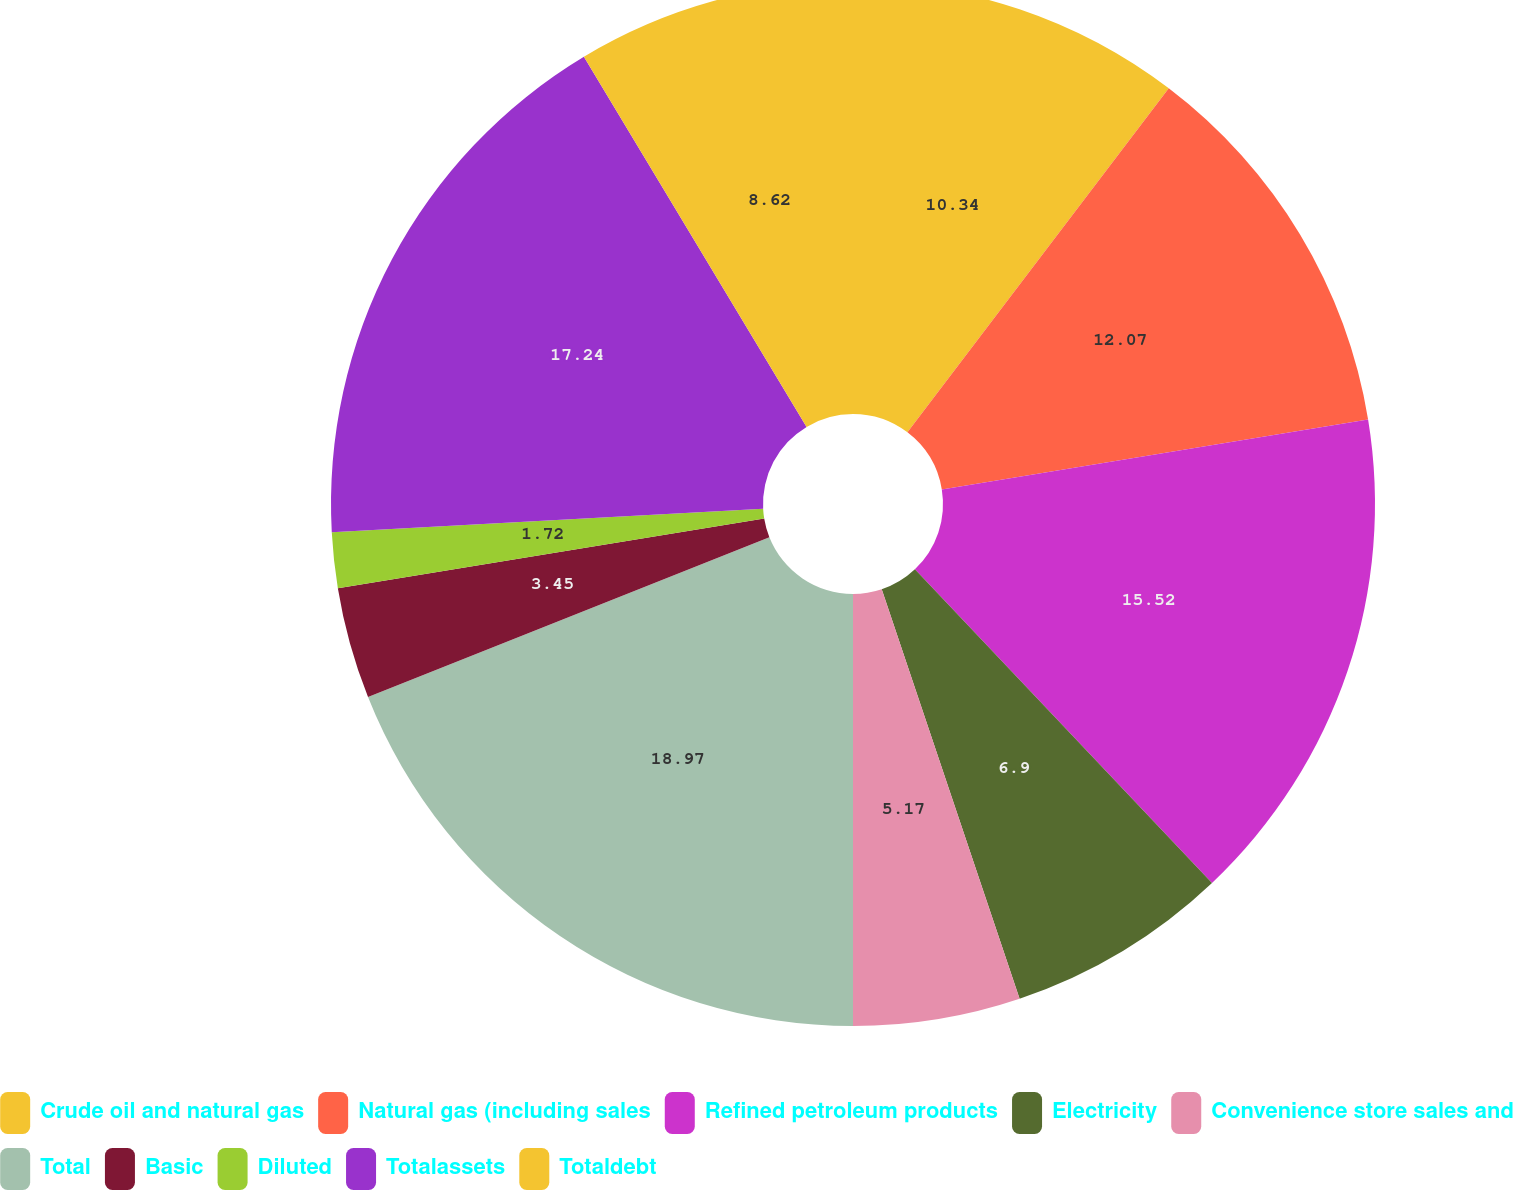Convert chart. <chart><loc_0><loc_0><loc_500><loc_500><pie_chart><fcel>Crude oil and natural gas<fcel>Natural gas (including sales<fcel>Refined petroleum products<fcel>Electricity<fcel>Convenience store sales and<fcel>Total<fcel>Basic<fcel>Diluted<fcel>Totalassets<fcel>Totaldebt<nl><fcel>10.34%<fcel>12.07%<fcel>15.52%<fcel>6.9%<fcel>5.17%<fcel>18.97%<fcel>3.45%<fcel>1.72%<fcel>17.24%<fcel>8.62%<nl></chart> 